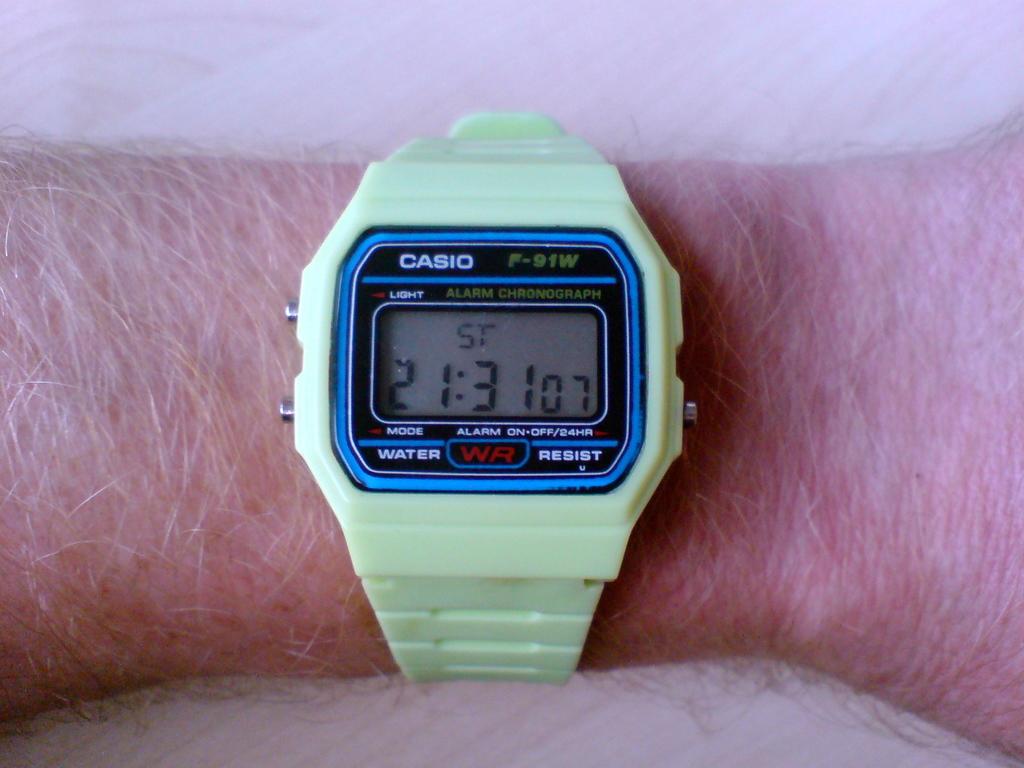Who made this watch?
Give a very brief answer. Casio. What time is it?
Offer a terse response. 21:31. 